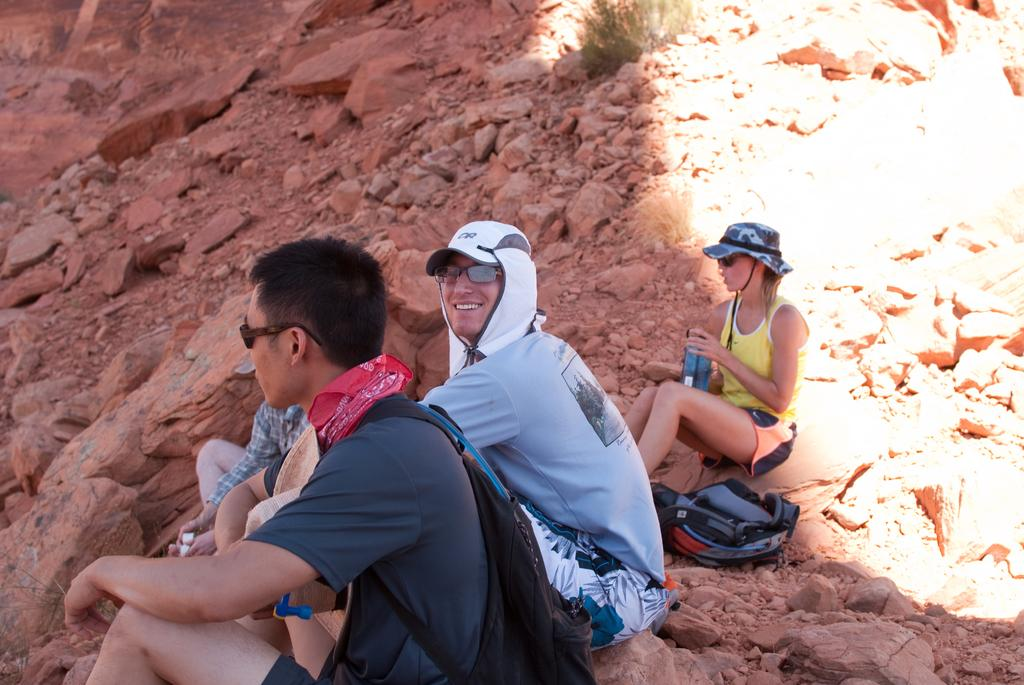How many people are in the foreground of the image? There are three men and a woman in the foreground of the image. What are the people in the foreground doing? They are sitting on a rock. What can be seen in the background of the image? In the background, there are stones and the rock is visible. What object is present on the right side of the image? There is a sunshade on the right side of the image. How many spiders are crawling on the woman's shoulder in the image? There are no spiders present in the image. What type of game are the men playing in the image? There is no game being played in the image; the people are sitting on a rock. 